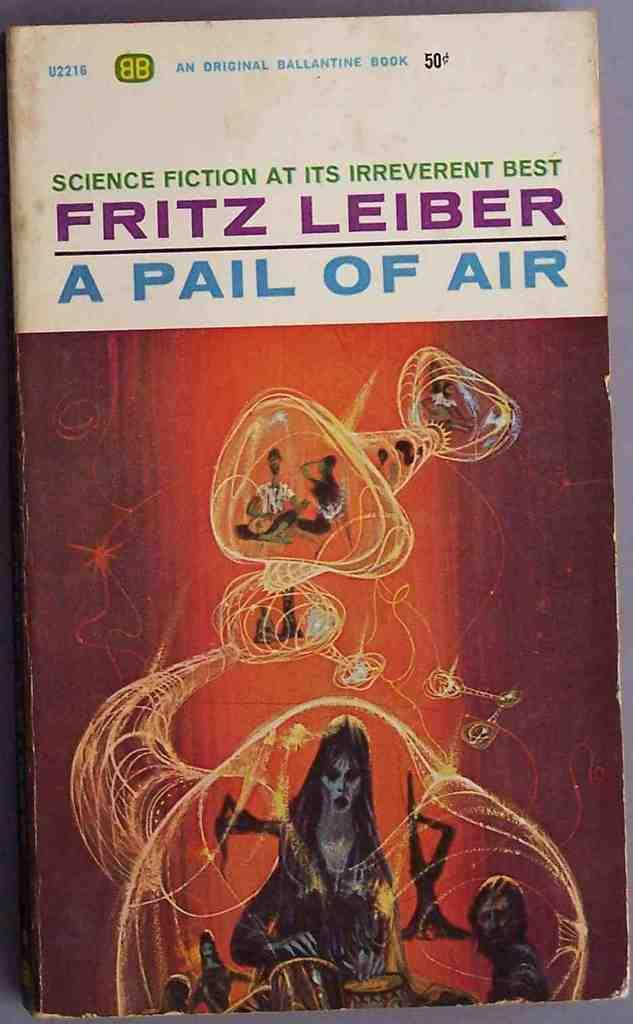<image>
Render a clear and concise summary of the photo. A book titled A Pail of Air written by Fritz Leiber. 